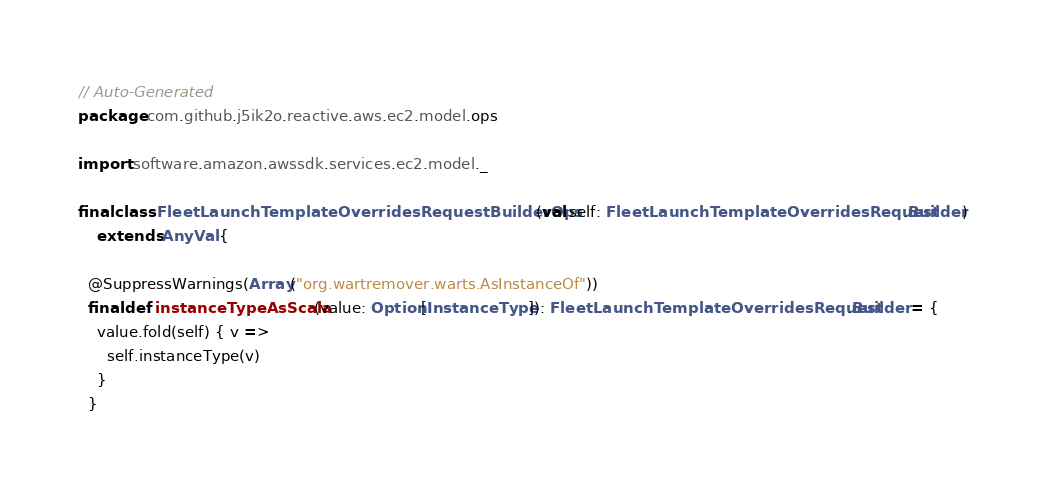<code> <loc_0><loc_0><loc_500><loc_500><_Scala_>// Auto-Generated
package com.github.j5ik2o.reactive.aws.ec2.model.ops

import software.amazon.awssdk.services.ec2.model._

final class FleetLaunchTemplateOverridesRequestBuilderOps(val self: FleetLaunchTemplateOverridesRequest.Builder)
    extends AnyVal {

  @SuppressWarnings(Array("org.wartremover.warts.AsInstanceOf"))
  final def instanceTypeAsScala(value: Option[InstanceType]): FleetLaunchTemplateOverridesRequest.Builder = {
    value.fold(self) { v =>
      self.instanceType(v)
    }
  }
</code> 